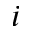Convert formula to latex. <formula><loc_0><loc_0><loc_500><loc_500>i</formula> 